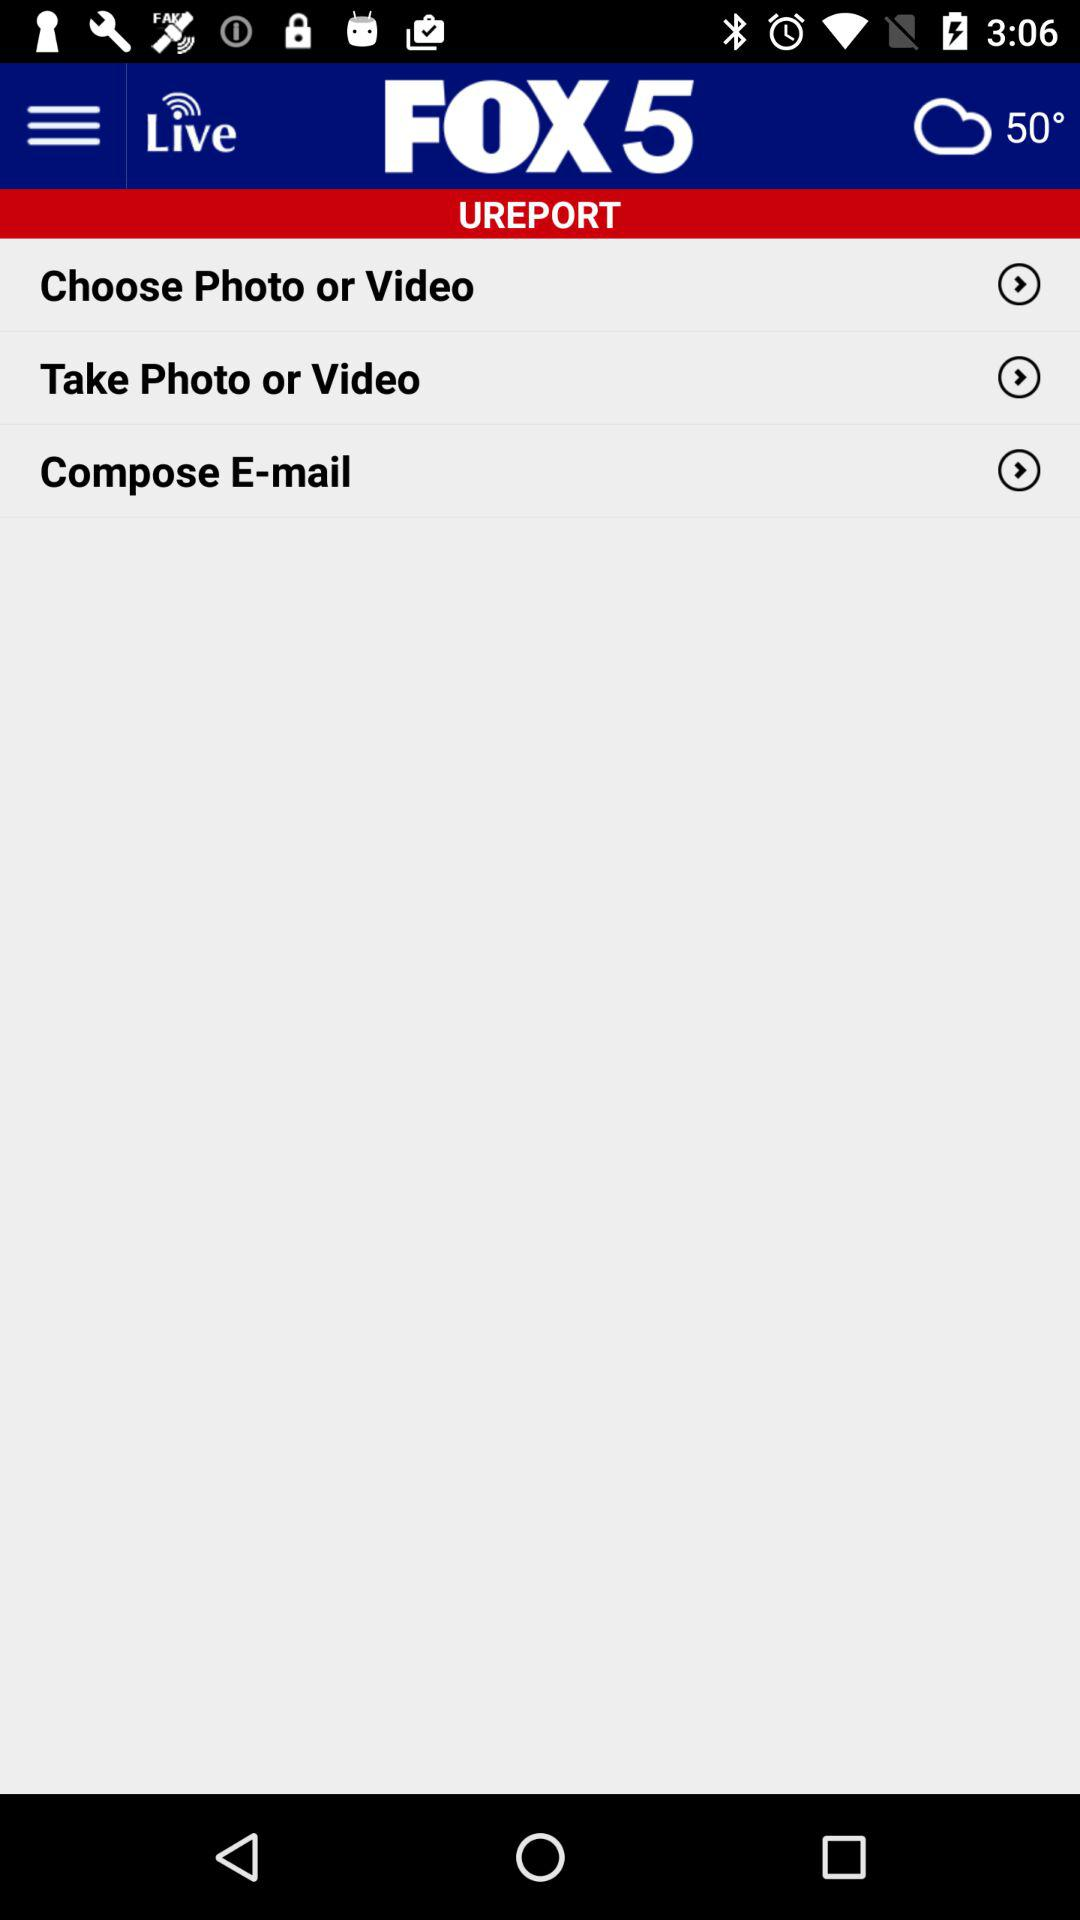What is the temperature? The temperature is 50°. 